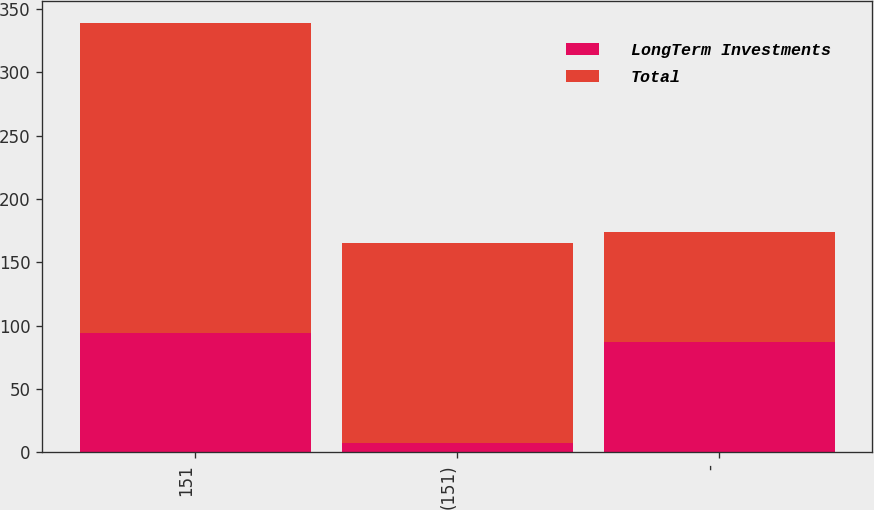Convert chart. <chart><loc_0><loc_0><loc_500><loc_500><stacked_bar_chart><ecel><fcel>151<fcel>(151)<fcel>-<nl><fcel>LongTerm Investments<fcel>94<fcel>7<fcel>87<nl><fcel>Total<fcel>245<fcel>158<fcel>87<nl></chart> 